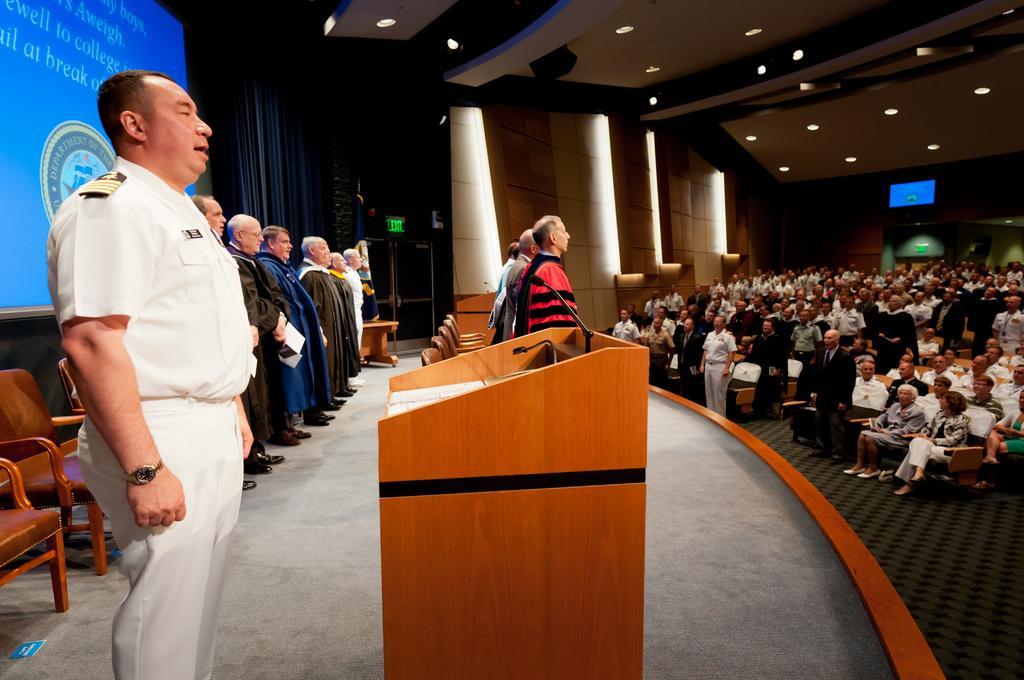Please provide a concise description of this image. This image consists of many persons. In the front, we can see few persons on the dais standing and singing. And we can see a podium made up of wood. On the right, there is a huge crowd. At the top, there is a roof along with light. In the background, there are pillars. On the left, we can see a screen along with the chairs. 